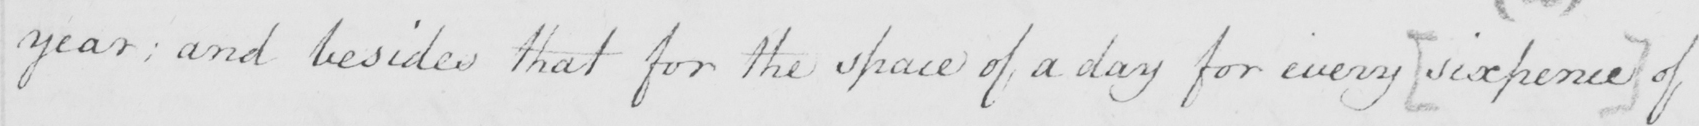What text is written in this handwritten line? year ; and besides that for the space of a day for every  [ sixpence ]  of 